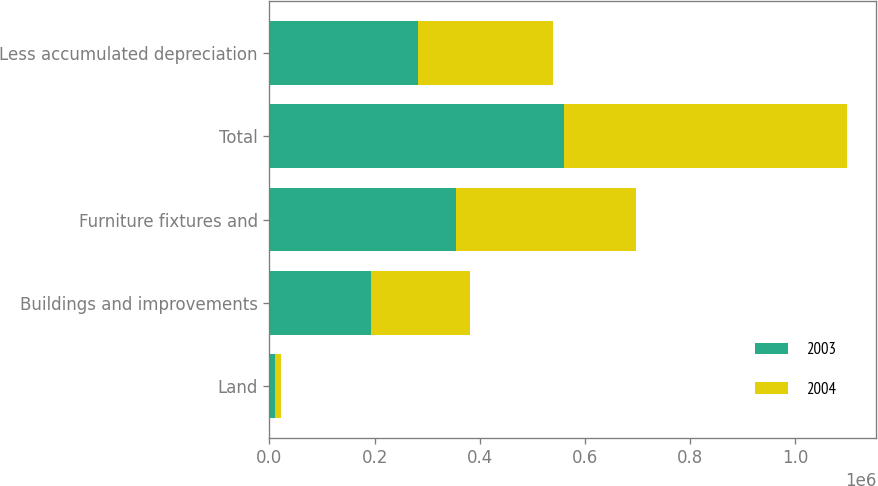<chart> <loc_0><loc_0><loc_500><loc_500><stacked_bar_chart><ecel><fcel>Land<fcel>Buildings and improvements<fcel>Furniture fixtures and<fcel>Total<fcel>Less accumulated depreciation<nl><fcel>2003<fcel>10831<fcel>193586<fcel>355248<fcel>559665<fcel>282577<nl><fcel>2004<fcel>10781<fcel>187375<fcel>341474<fcel>539630<fcel>255868<nl></chart> 